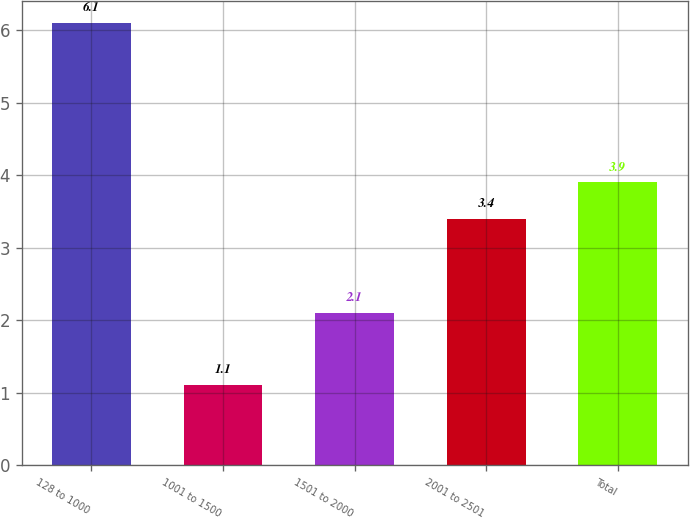<chart> <loc_0><loc_0><loc_500><loc_500><bar_chart><fcel>128 to 1000<fcel>1001 to 1500<fcel>1501 to 2000<fcel>2001 to 2501<fcel>Total<nl><fcel>6.1<fcel>1.1<fcel>2.1<fcel>3.4<fcel>3.9<nl></chart> 